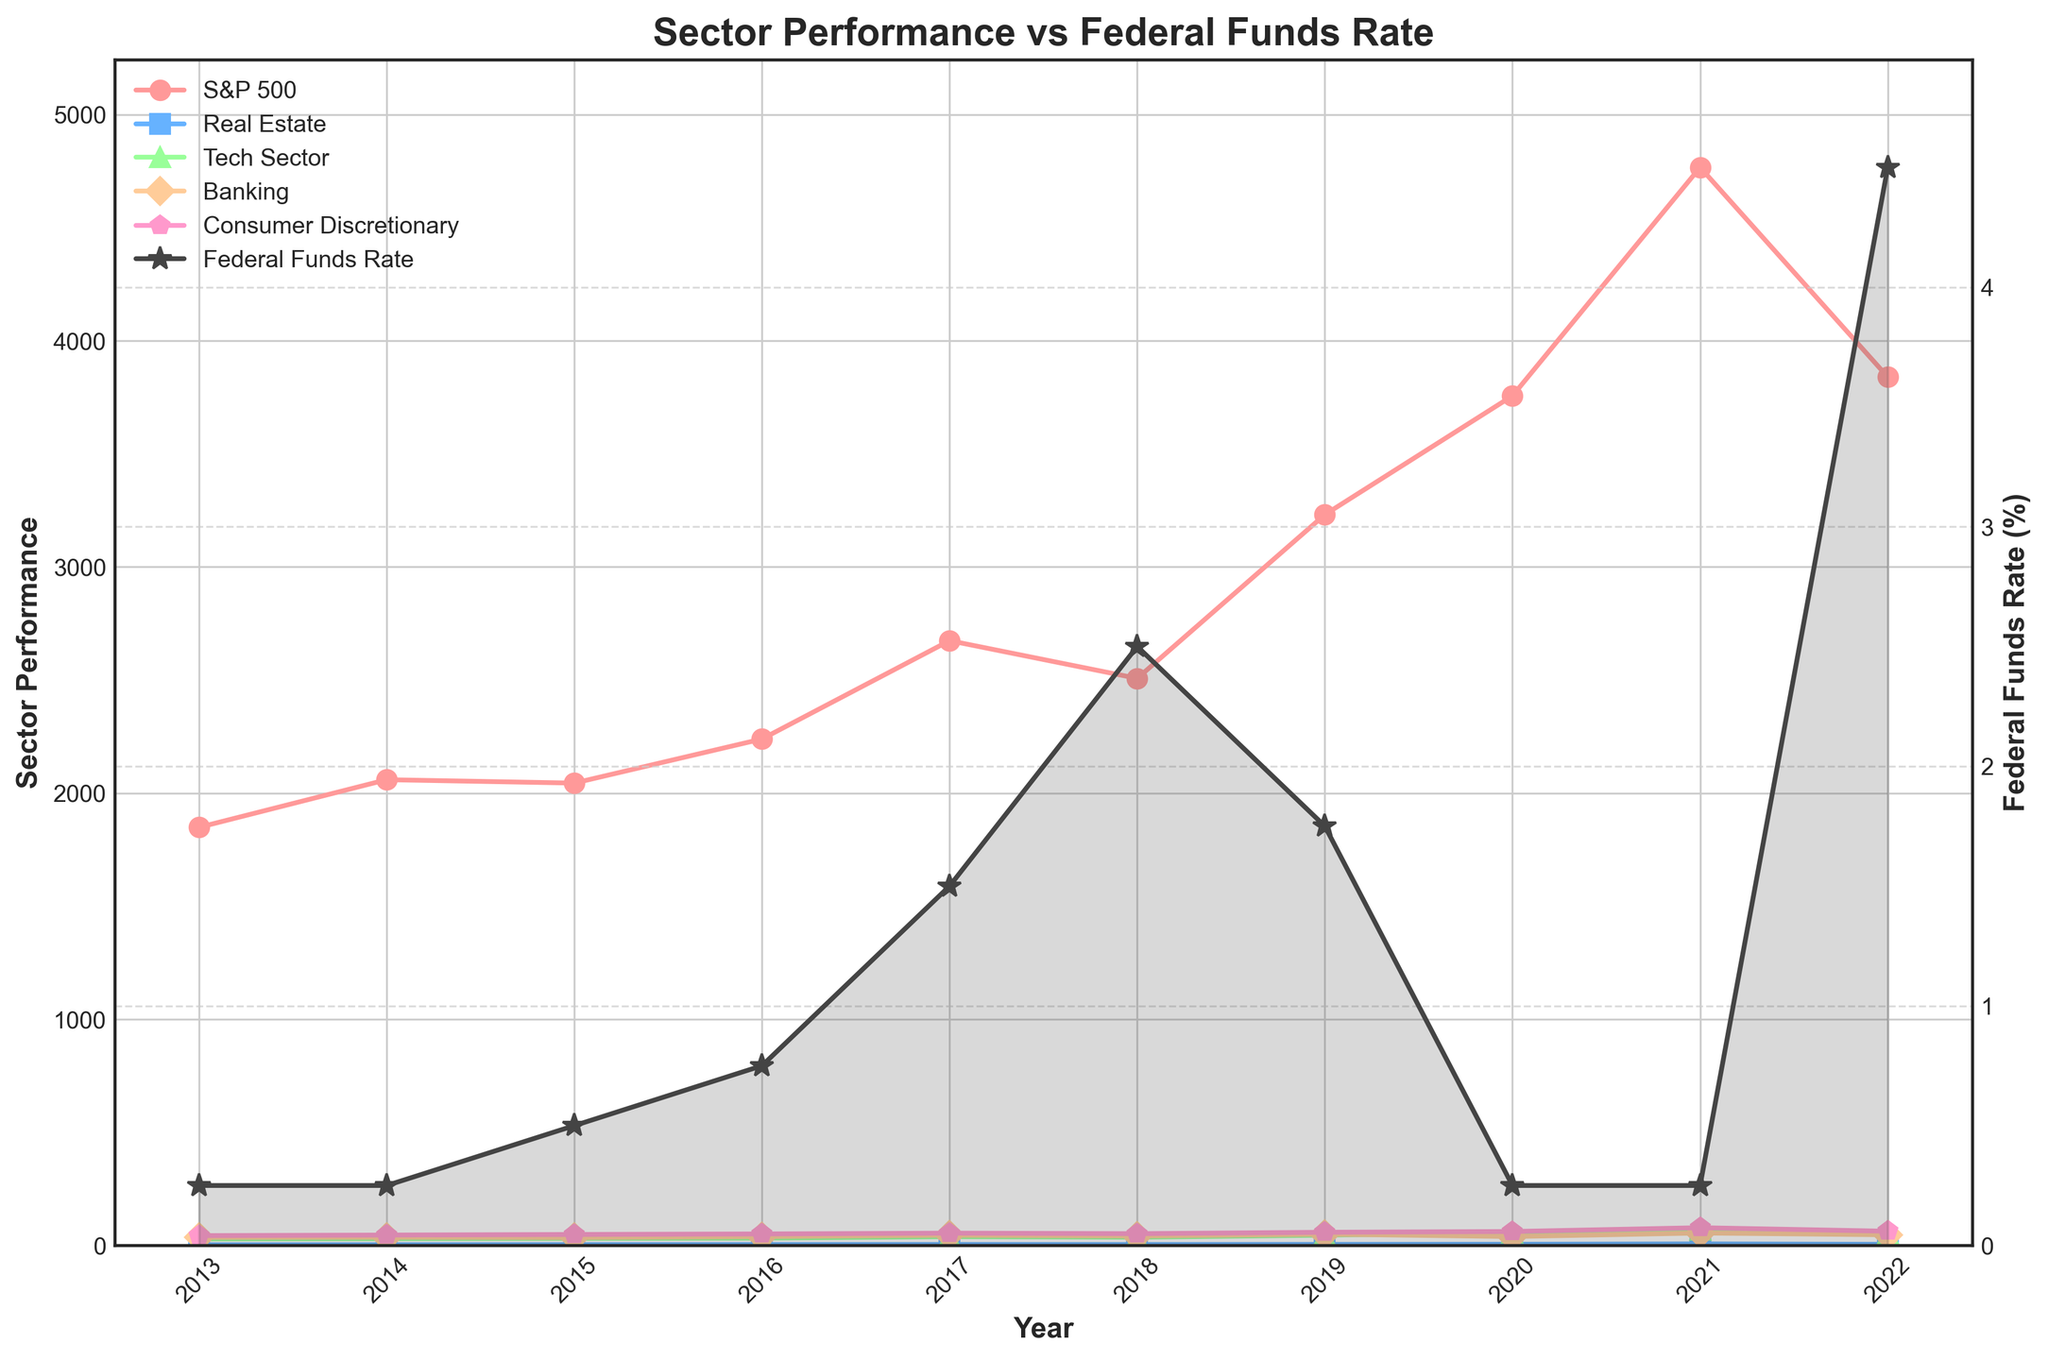Which sector had the highest performance in 2021? In 2021, the values for each sector need to be checked. The Tech Sector had the highest value at 68.2.
Answer: Tech Sector How did the Federal Funds Rate change between 2017 and 2022? The Federal Funds Rate increased from 1.50% in 2017 to 4.50% in 2022 by examining the y-axis values for these years.
Answer: Increased Which sector showed a decline in performance between 2021 and 2022? By looking at the graph, the Real Estate sector decreased from 6.7 to 4.8, and the Tech Sector decreased from 68.2 to 51.4. Both sectors had a decline, so any one of them can be the answer.
Answer: Real Estate or Tech Sector During which year did the S&P 500 have a drastic rise? Examining the S&P 500 values year by year, the most significant rise occurred from 2019 (3230.78) to 2020 (3756.07).
Answer: 2020 Compare the Federal Funds Rate in the years 2013 and 2020. The Federal Funds Rate in both years was the same, at 0.25%.
Answer: Equal What was the average performance of the Consumer Discretionary sector from 2013 to 2022? Summing values from the Consumer Discretionary sector and dividing by the number of years yields (43.2 + 45.8 + 48.3 + 50.7 + 54.2 + 51.9 + 58.1 + 61.4 + 78.3 + 62.7)/10 = 55.66.
Answer: 55.66 Which sector appears to follow a trend similar to the Federal Funds Rate? The Banking sector shows a trend that aligns closely with the Federal Funds Rate from 2017 to 2022.
Answer: Banking Identify the year in which the Tech Sector had the lowest performance. By analyzing the graph, the lowest performance in the Tech Sector occurred in 2013, with a value of 28.4.
Answer: 2013 Which sector did the best in a year when the Federal Funds Rate was at its lowest? The Federal Funds Rate was lowest at 0.25% in 2013, 2014, 2020, and 2021. The Tech Sector had the best performance in 2021 with 68.2.
Answer: Tech Sector What was the difference in Banking sector performance between 2015 and 2019? For the Banking sector, the performance in 2015 was 34.8 and in 2019 was 49.6. The difference is 49.6 - 34.8 = 14.8.
Answer: 14.8 